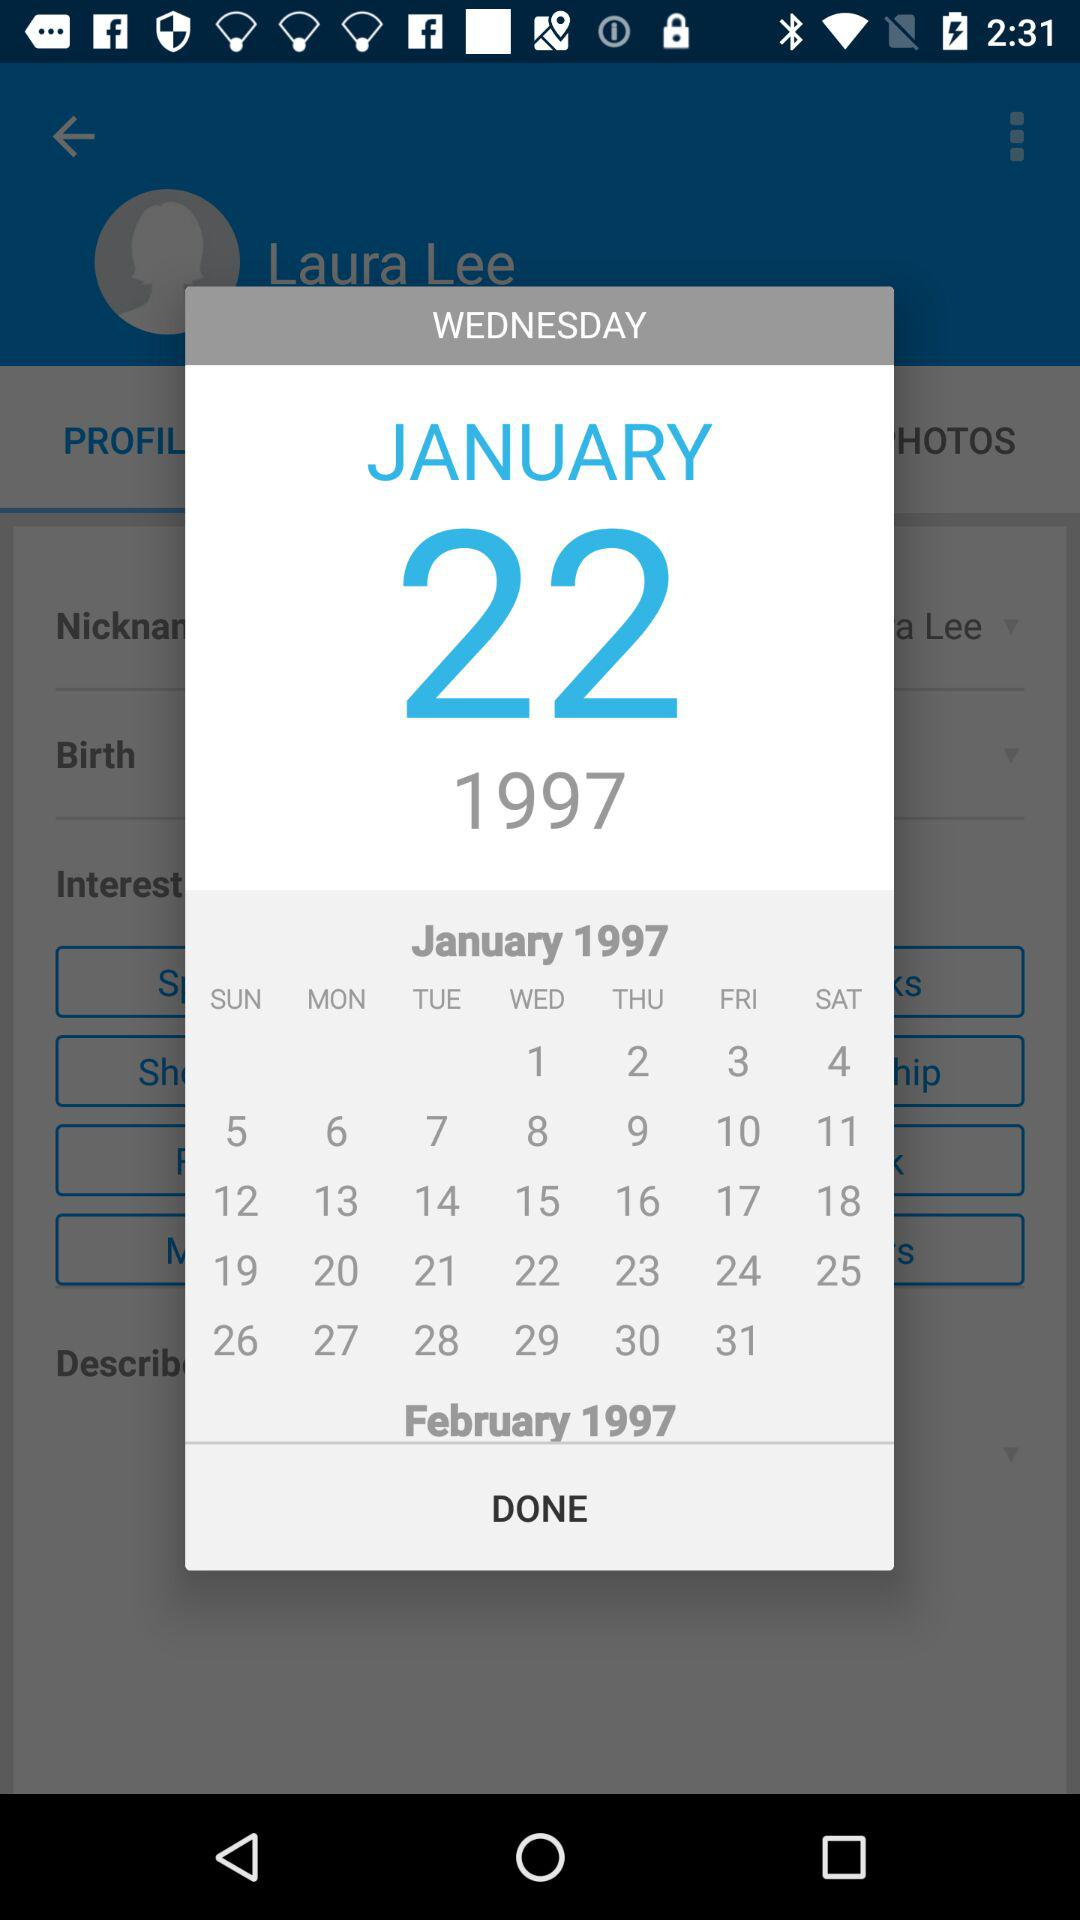What is the given year? The given year is 1997. 